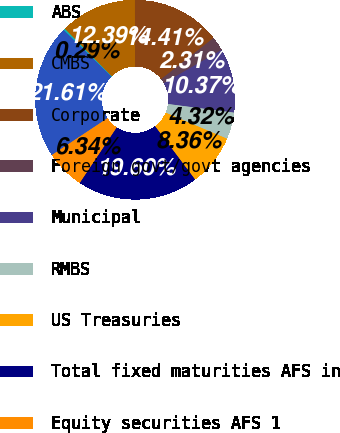Convert chart to OTSL. <chart><loc_0><loc_0><loc_500><loc_500><pie_chart><fcel>ABS<fcel>CMBS<fcel>Corporate<fcel>Foreign govt/govt agencies<fcel>Municipal<fcel>RMBS<fcel>US Treasuries<fcel>Total fixed maturities AFS in<fcel>Equity securities AFS 1<fcel>Total securities in an<nl><fcel>0.29%<fcel>12.39%<fcel>14.41%<fcel>2.31%<fcel>10.37%<fcel>4.32%<fcel>8.36%<fcel>19.6%<fcel>6.34%<fcel>21.61%<nl></chart> 